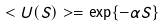<formula> <loc_0><loc_0><loc_500><loc_500>< U ( S ) > = \exp \{ - \alpha S \}</formula> 